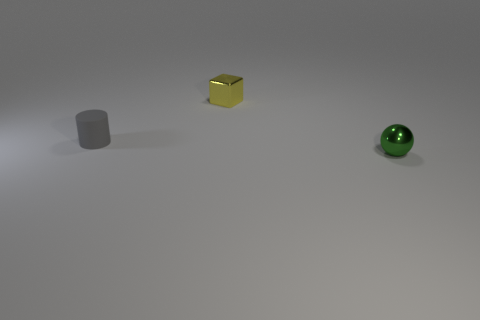The green metal thing has what shape?
Offer a very short reply. Sphere. There is a block that is behind the gray rubber cylinder; what is its size?
Provide a succinct answer. Small. What is the color of the other matte object that is the same size as the yellow object?
Provide a succinct answer. Gray. Are there any small blocks that have the same color as the tiny matte cylinder?
Keep it short and to the point. No. Is the number of tiny green balls that are behind the tiny yellow object less than the number of tiny yellow objects on the right side of the tiny gray rubber thing?
Give a very brief answer. Yes. The thing that is in front of the yellow object and behind the green metal object is made of what material?
Provide a short and direct response. Rubber. Do the matte thing and the metal thing behind the cylinder have the same shape?
Ensure brevity in your answer.  No. Is the number of green shiny spheres greater than the number of gray shiny blocks?
Your response must be concise. Yes. What number of objects are behind the gray thing and on the right side of the small metallic block?
Offer a terse response. 0. What shape is the tiny thing in front of the small gray cylinder that is in front of the metal thing that is behind the green sphere?
Provide a succinct answer. Sphere. 